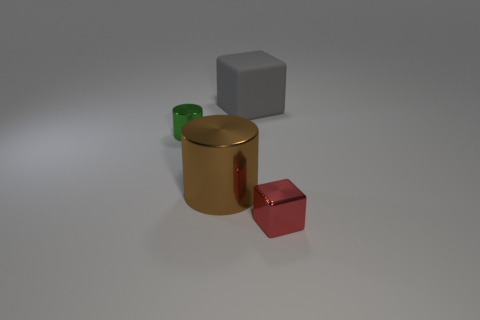What could be the function of the green object? The green object appears to be a transparent cup, possibly made of glass or plastic. Its function could be to hold liquids for drinking. 